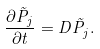Convert formula to latex. <formula><loc_0><loc_0><loc_500><loc_500>\frac { \partial \tilde { P } _ { j } } { \partial t } = D \tilde { P } _ { j } .</formula> 